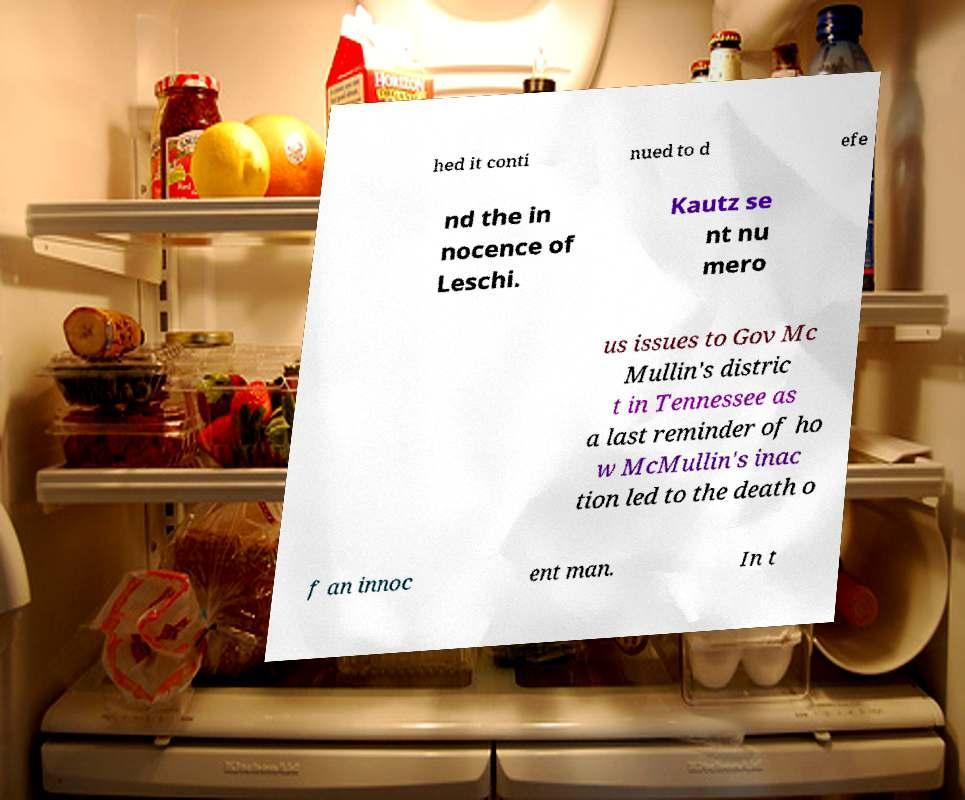Can you read and provide the text displayed in the image?This photo seems to have some interesting text. Can you extract and type it out for me? hed it conti nued to d efe nd the in nocence of Leschi. Kautz se nt nu mero us issues to Gov Mc Mullin's distric t in Tennessee as a last reminder of ho w McMullin's inac tion led to the death o f an innoc ent man. In t 